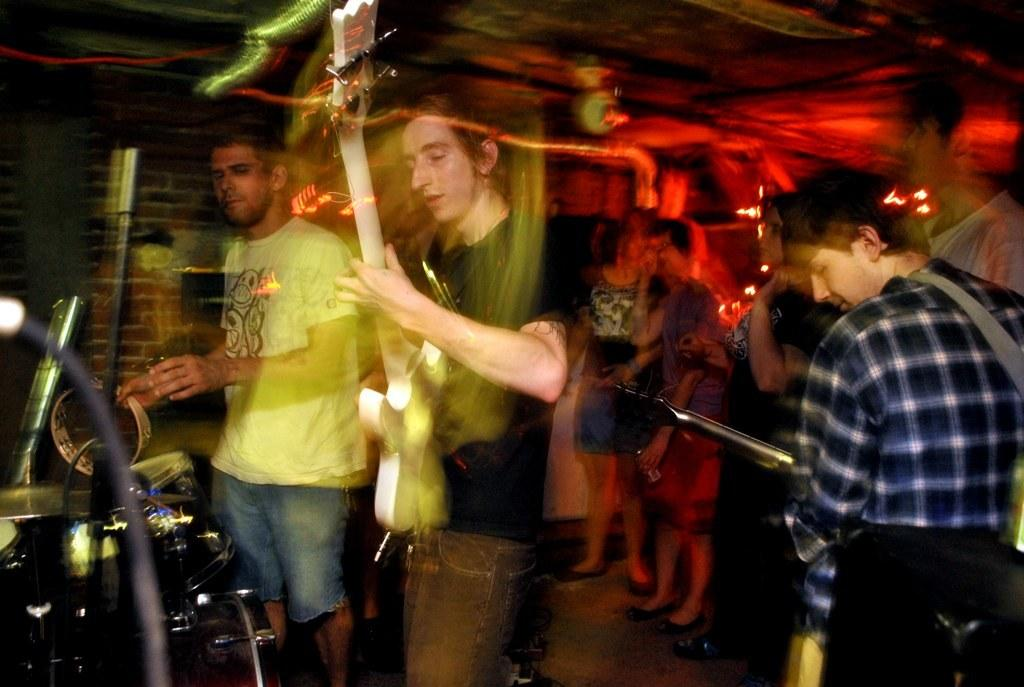What is happening in the image involving the people? Some people are holding musical instruments, and some are dancing. Can you describe the actions of the people with musical instruments? The people with musical instruments are holding them, which suggests they might be playing or preparing to play. What is the overall condition of the image? The image is blurred. What type of salt can be seen on the scale in the image? There is no salt or scale present in the image. Can you describe the cat's behavior in the image? There is no cat present in the image. 